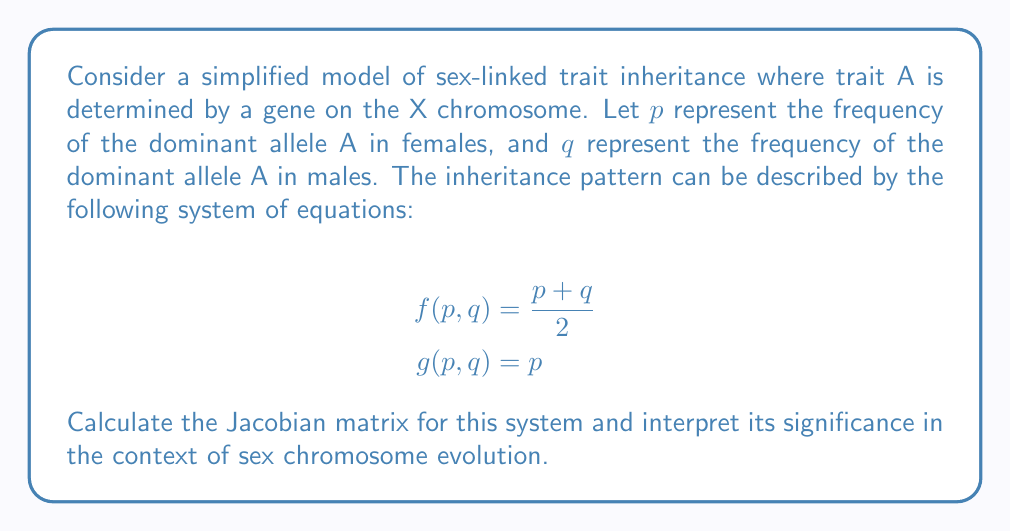Can you solve this math problem? To solve this problem, we'll follow these steps:

1) First, recall that the Jacobian matrix is defined as:

   $$J = \begin{bmatrix}
   \frac{\partial f}{\partial p} & \frac{\partial f}{\partial q} \\
   \frac{\partial g}{\partial p} & \frac{\partial g}{\partial q}
   \end{bmatrix}$$

2) Let's calculate each partial derivative:

   $\frac{\partial f}{\partial p} = \frac{\partial}{\partial p}(\frac{p + q}{2}) = \frac{1}{2}$

   $\frac{\partial f}{\partial q} = \frac{\partial}{\partial q}(\frac{p + q}{2}) = \frac{1}{2}$

   $\frac{\partial g}{\partial p} = \frac{\partial}{\partial p}(p) = 1$

   $\frac{\partial g}{\partial q} = \frac{\partial}{\partial q}(p) = 0$

3) Now we can construct the Jacobian matrix:

   $$J = \begin{bmatrix}
   \frac{1}{2} & \frac{1}{2} \\
   1 & 0
   \end{bmatrix}$$

4) Interpretation: The Jacobian matrix represents the rate of change of the allele frequencies in the next generation with respect to the current generation. In the context of sex chromosome evolution:

   - The $\frac{1}{2}$ entries in the first row indicate that the frequency of the allele in females in the next generation is equally influenced by both male and female frequencies in the current generation.
   - The second row (1, 0) shows that the frequency in males in the next generation is solely determined by the female frequency in the current generation, reflecting the fact that males inherit their X chromosome only from their mother.

This Jacobian captures the asymmetry in inheritance patterns between sexes, which is a key feature in sex chromosome evolution. It highlights how changes in allele frequencies can propagate differently through male and female lineages, potentially leading to sex-specific selection pressures and divergent evolution of sex chromosomes.
Answer: $$J = \begin{bmatrix}
\frac{1}{2} & \frac{1}{2} \\
1 & 0
\end{bmatrix}$$ 